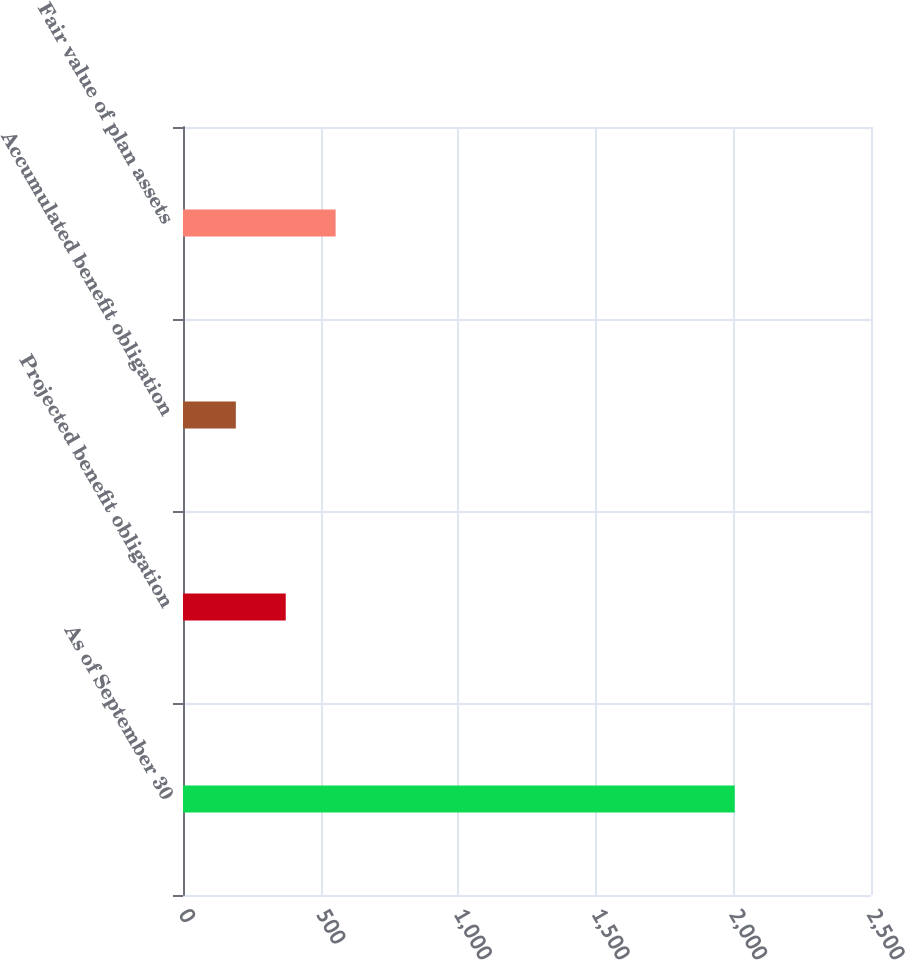<chart> <loc_0><loc_0><loc_500><loc_500><bar_chart><fcel>As of September 30<fcel>Projected benefit obligation<fcel>Accumulated benefit obligation<fcel>Fair value of plan assets<nl><fcel>2005<fcel>373.3<fcel>192<fcel>554.6<nl></chart> 